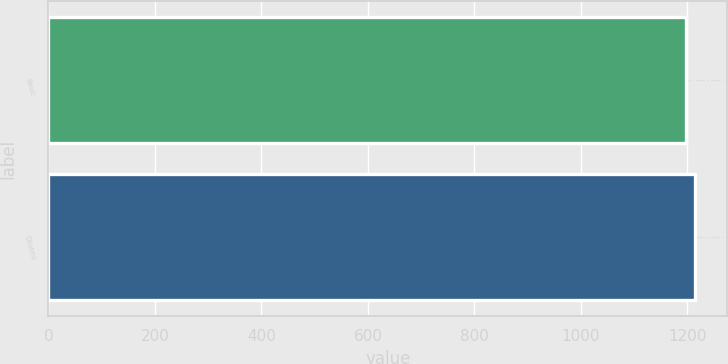Convert chart. <chart><loc_0><loc_0><loc_500><loc_500><bar_chart><fcel>Basic<fcel>Diluted<nl><fcel>1198<fcel>1214<nl></chart> 